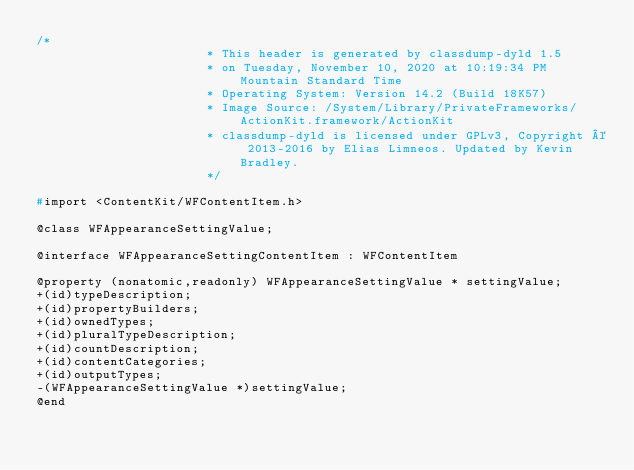<code> <loc_0><loc_0><loc_500><loc_500><_C_>/*
                       * This header is generated by classdump-dyld 1.5
                       * on Tuesday, November 10, 2020 at 10:19:34 PM Mountain Standard Time
                       * Operating System: Version 14.2 (Build 18K57)
                       * Image Source: /System/Library/PrivateFrameworks/ActionKit.framework/ActionKit
                       * classdump-dyld is licensed under GPLv3, Copyright © 2013-2016 by Elias Limneos. Updated by Kevin Bradley.
                       */

#import <ContentKit/WFContentItem.h>

@class WFAppearanceSettingValue;

@interface WFAppearanceSettingContentItem : WFContentItem

@property (nonatomic,readonly) WFAppearanceSettingValue * settingValue; 
+(id)typeDescription;
+(id)propertyBuilders;
+(id)ownedTypes;
+(id)pluralTypeDescription;
+(id)countDescription;
+(id)contentCategories;
+(id)outputTypes;
-(WFAppearanceSettingValue *)settingValue;
@end

</code> 